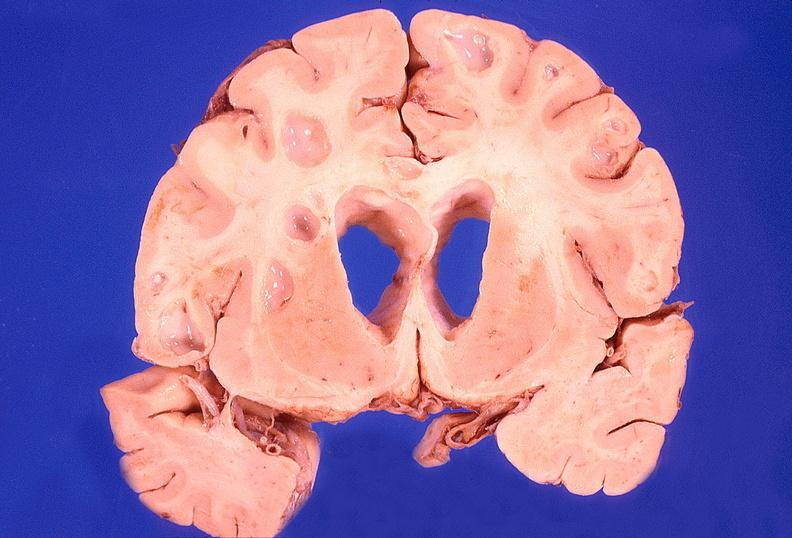s nervous present?
Answer the question using a single word or phrase. Yes 